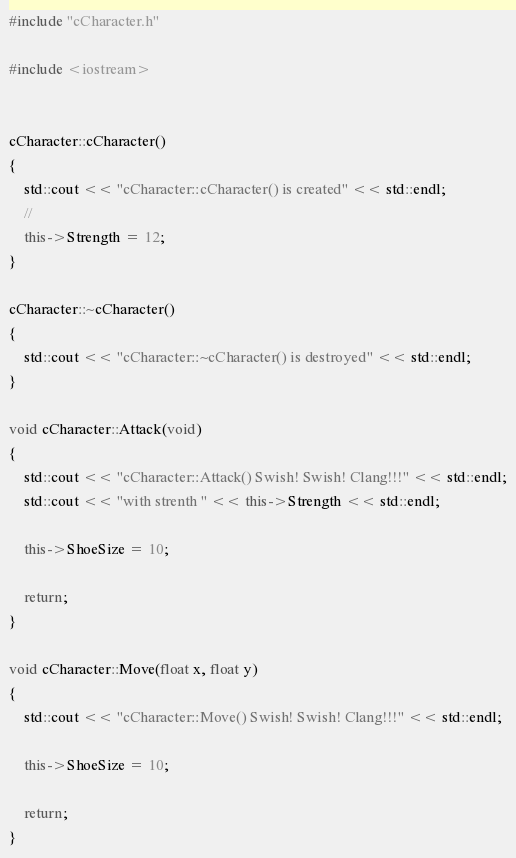Convert code to text. <code><loc_0><loc_0><loc_500><loc_500><_C++_>#include "cCharacter.h"

#include <iostream>


cCharacter::cCharacter()
{
	std::cout << "cCharacter::cCharacter() is created" << std::endl;
	//
	this->Strength = 12;
}

cCharacter::~cCharacter()
{
	std::cout << "cCharacter::~cCharacter() is destroyed" << std::endl;
}

void cCharacter::Attack(void)
{
	std::cout << "cCharacter::Attack() Swish! Swish! Clang!!!" << std::endl;
	std::cout << "with strenth " << this->Strength << std::endl;

	this->ShoeSize = 10;

	return;
}

void cCharacter::Move(float x, float y)
{
	std::cout << "cCharacter::Move() Swish! Swish! Clang!!!" << std::endl;

	this->ShoeSize = 10;

	return;
}</code> 